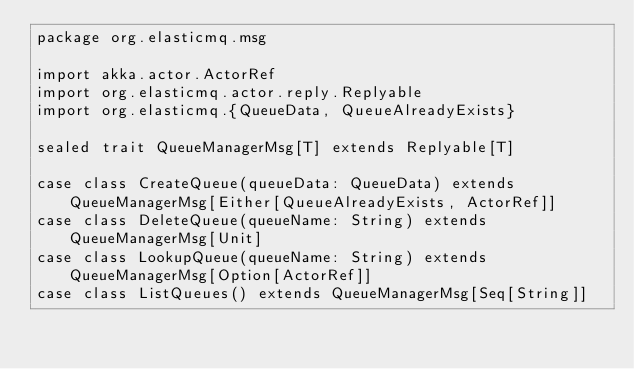<code> <loc_0><loc_0><loc_500><loc_500><_Scala_>package org.elasticmq.msg

import akka.actor.ActorRef
import org.elasticmq.actor.reply.Replyable
import org.elasticmq.{QueueData, QueueAlreadyExists}

sealed trait QueueManagerMsg[T] extends Replyable[T]

case class CreateQueue(queueData: QueueData) extends QueueManagerMsg[Either[QueueAlreadyExists, ActorRef]]
case class DeleteQueue(queueName: String) extends QueueManagerMsg[Unit]
case class LookupQueue(queueName: String) extends QueueManagerMsg[Option[ActorRef]]
case class ListQueues() extends QueueManagerMsg[Seq[String]]</code> 